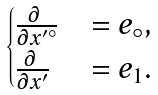<formula> <loc_0><loc_0><loc_500><loc_500>\begin{cases} \frac { \partial \ } { \partial x ^ { \prime \circ } } & = e _ { \circ } , \\ \frac { \partial \ } { \partial x ^ { \prime } } & = e _ { 1 } . \\ \end{cases}</formula> 